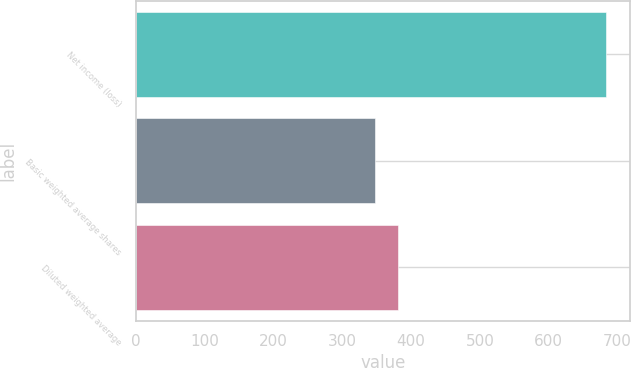Convert chart to OTSL. <chart><loc_0><loc_0><loc_500><loc_500><bar_chart><fcel>Net income (loss)<fcel>Basic weighted average shares<fcel>Diluted weighted average<nl><fcel>684<fcel>347<fcel>380.7<nl></chart> 